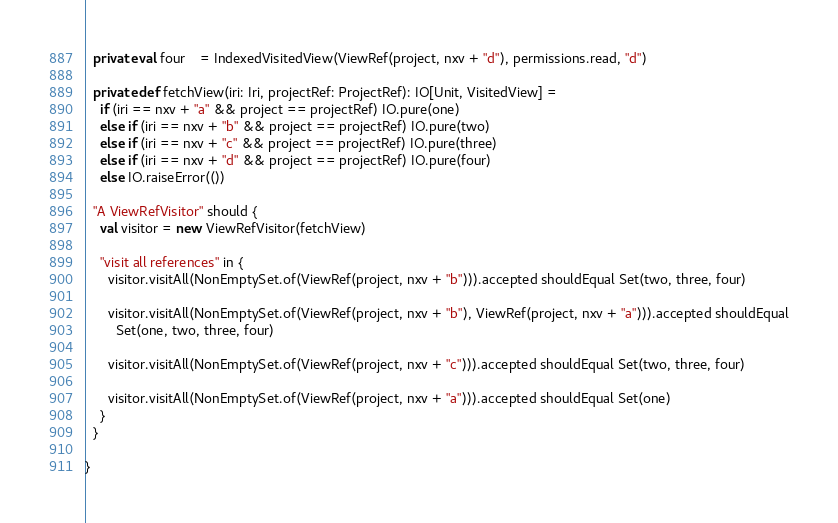Convert code to text. <code><loc_0><loc_0><loc_500><loc_500><_Scala_>  private val four    = IndexedVisitedView(ViewRef(project, nxv + "d"), permissions.read, "d")

  private def fetchView(iri: Iri, projectRef: ProjectRef): IO[Unit, VisitedView] =
    if (iri == nxv + "a" && project == projectRef) IO.pure(one)
    else if (iri == nxv + "b" && project == projectRef) IO.pure(two)
    else if (iri == nxv + "c" && project == projectRef) IO.pure(three)
    else if (iri == nxv + "d" && project == projectRef) IO.pure(four)
    else IO.raiseError(())

  "A ViewRefVisitor" should {
    val visitor = new ViewRefVisitor(fetchView)

    "visit all references" in {
      visitor.visitAll(NonEmptySet.of(ViewRef(project, nxv + "b"))).accepted shouldEqual Set(two, three, four)

      visitor.visitAll(NonEmptySet.of(ViewRef(project, nxv + "b"), ViewRef(project, nxv + "a"))).accepted shouldEqual
        Set(one, two, three, four)

      visitor.visitAll(NonEmptySet.of(ViewRef(project, nxv + "c"))).accepted shouldEqual Set(two, three, four)

      visitor.visitAll(NonEmptySet.of(ViewRef(project, nxv + "a"))).accepted shouldEqual Set(one)
    }
  }

}
</code> 